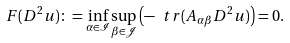Convert formula to latex. <formula><loc_0><loc_0><loc_500><loc_500>F ( D ^ { 2 } u ) \colon = \inf _ { \alpha \in \mathcal { I } } \sup _ { \beta \in \mathcal { J } } \left ( - \ t r ( A _ { \alpha \beta } D ^ { 2 } u ) \right ) = 0 .</formula> 